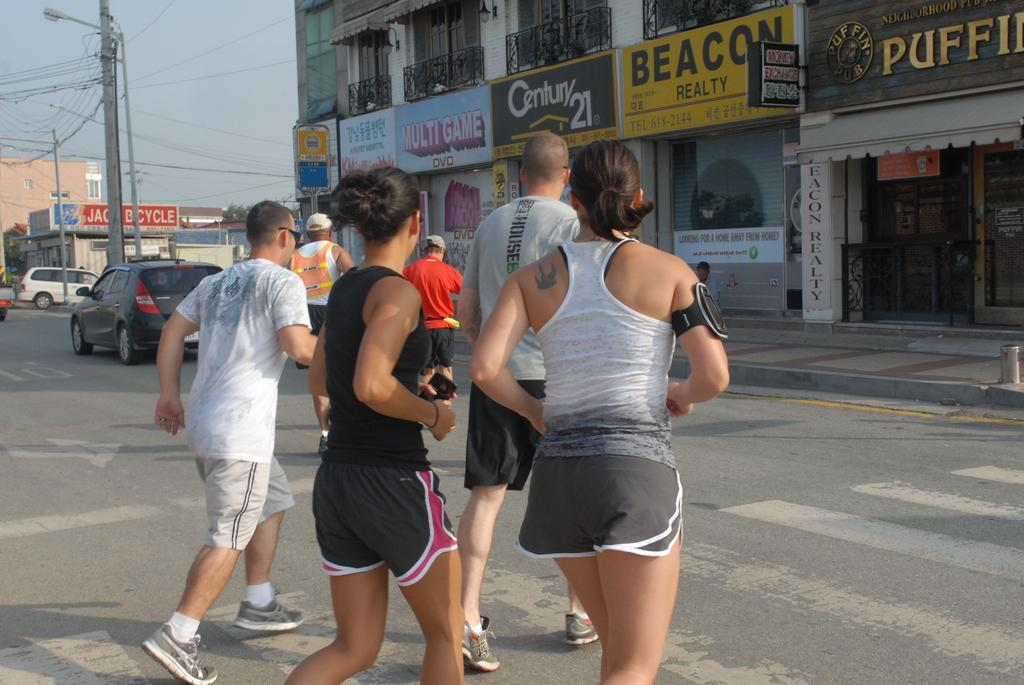<image>
Offer a succinct explanation of the picture presented. A group of people run across the street towards the Beacon Realty building. 